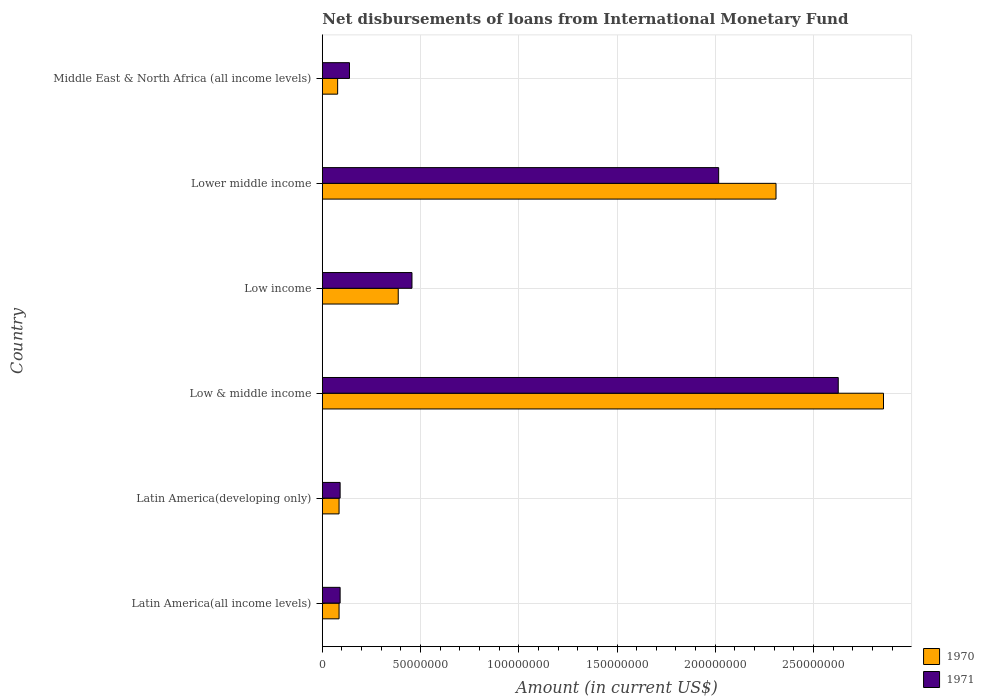What is the amount of loans disbursed in 1971 in Latin America(all income levels)?
Offer a very short reply. 9.06e+06. Across all countries, what is the maximum amount of loans disbursed in 1970?
Provide a succinct answer. 2.86e+08. Across all countries, what is the minimum amount of loans disbursed in 1971?
Keep it short and to the point. 9.06e+06. In which country was the amount of loans disbursed in 1970 minimum?
Your answer should be compact. Middle East & North Africa (all income levels). What is the total amount of loans disbursed in 1971 in the graph?
Your answer should be compact. 5.42e+08. What is the difference between the amount of loans disbursed in 1970 in Latin America(developing only) and that in Low & middle income?
Your answer should be very brief. -2.77e+08. What is the difference between the amount of loans disbursed in 1970 in Low income and the amount of loans disbursed in 1971 in Latin America(all income levels)?
Offer a very short reply. 2.96e+07. What is the average amount of loans disbursed in 1970 per country?
Provide a succinct answer. 9.67e+07. What is the difference between the amount of loans disbursed in 1971 and amount of loans disbursed in 1970 in Middle East & North Africa (all income levels)?
Offer a very short reply. 6.03e+06. In how many countries, is the amount of loans disbursed in 1971 greater than 280000000 US$?
Provide a short and direct response. 0. What is the ratio of the amount of loans disbursed in 1971 in Lower middle income to that in Middle East & North Africa (all income levels)?
Your response must be concise. 14.6. What is the difference between the highest and the second highest amount of loans disbursed in 1971?
Offer a very short reply. 6.09e+07. What is the difference between the highest and the lowest amount of loans disbursed in 1971?
Make the answer very short. 2.54e+08. In how many countries, is the amount of loans disbursed in 1971 greater than the average amount of loans disbursed in 1971 taken over all countries?
Offer a very short reply. 2. What does the 1st bar from the bottom in Middle East & North Africa (all income levels) represents?
Offer a terse response. 1970. What is the difference between two consecutive major ticks on the X-axis?
Offer a very short reply. 5.00e+07. Are the values on the major ticks of X-axis written in scientific E-notation?
Your response must be concise. No. Does the graph contain any zero values?
Give a very brief answer. No. How are the legend labels stacked?
Give a very brief answer. Vertical. What is the title of the graph?
Ensure brevity in your answer.  Net disbursements of loans from International Monetary Fund. What is the label or title of the Y-axis?
Your response must be concise. Country. What is the Amount (in current US$) of 1970 in Latin America(all income levels)?
Ensure brevity in your answer.  8.52e+06. What is the Amount (in current US$) in 1971 in Latin America(all income levels)?
Your response must be concise. 9.06e+06. What is the Amount (in current US$) in 1970 in Latin America(developing only)?
Keep it short and to the point. 8.52e+06. What is the Amount (in current US$) in 1971 in Latin America(developing only)?
Provide a short and direct response. 9.06e+06. What is the Amount (in current US$) of 1970 in Low & middle income?
Your answer should be very brief. 2.86e+08. What is the Amount (in current US$) of 1971 in Low & middle income?
Your answer should be very brief. 2.63e+08. What is the Amount (in current US$) in 1970 in Low income?
Ensure brevity in your answer.  3.86e+07. What is the Amount (in current US$) in 1971 in Low income?
Keep it short and to the point. 4.56e+07. What is the Amount (in current US$) of 1970 in Lower middle income?
Your answer should be very brief. 2.31e+08. What is the Amount (in current US$) in 1971 in Lower middle income?
Give a very brief answer. 2.02e+08. What is the Amount (in current US$) of 1970 in Middle East & North Africa (all income levels)?
Ensure brevity in your answer.  7.79e+06. What is the Amount (in current US$) of 1971 in Middle East & North Africa (all income levels)?
Give a very brief answer. 1.38e+07. Across all countries, what is the maximum Amount (in current US$) in 1970?
Keep it short and to the point. 2.86e+08. Across all countries, what is the maximum Amount (in current US$) of 1971?
Ensure brevity in your answer.  2.63e+08. Across all countries, what is the minimum Amount (in current US$) in 1970?
Provide a succinct answer. 7.79e+06. Across all countries, what is the minimum Amount (in current US$) in 1971?
Provide a succinct answer. 9.06e+06. What is the total Amount (in current US$) in 1970 in the graph?
Keep it short and to the point. 5.80e+08. What is the total Amount (in current US$) in 1971 in the graph?
Make the answer very short. 5.42e+08. What is the difference between the Amount (in current US$) of 1970 in Latin America(all income levels) and that in Low & middle income?
Your response must be concise. -2.77e+08. What is the difference between the Amount (in current US$) of 1971 in Latin America(all income levels) and that in Low & middle income?
Keep it short and to the point. -2.54e+08. What is the difference between the Amount (in current US$) in 1970 in Latin America(all income levels) and that in Low income?
Make the answer very short. -3.01e+07. What is the difference between the Amount (in current US$) in 1971 in Latin America(all income levels) and that in Low income?
Your answer should be very brief. -3.66e+07. What is the difference between the Amount (in current US$) in 1970 in Latin America(all income levels) and that in Lower middle income?
Provide a succinct answer. -2.22e+08. What is the difference between the Amount (in current US$) in 1971 in Latin America(all income levels) and that in Lower middle income?
Your answer should be very brief. -1.93e+08. What is the difference between the Amount (in current US$) in 1970 in Latin America(all income levels) and that in Middle East & North Africa (all income levels)?
Your answer should be very brief. 7.24e+05. What is the difference between the Amount (in current US$) in 1971 in Latin America(all income levels) and that in Middle East & North Africa (all income levels)?
Offer a terse response. -4.76e+06. What is the difference between the Amount (in current US$) of 1970 in Latin America(developing only) and that in Low & middle income?
Provide a short and direct response. -2.77e+08. What is the difference between the Amount (in current US$) in 1971 in Latin America(developing only) and that in Low & middle income?
Offer a terse response. -2.54e+08. What is the difference between the Amount (in current US$) in 1970 in Latin America(developing only) and that in Low income?
Ensure brevity in your answer.  -3.01e+07. What is the difference between the Amount (in current US$) in 1971 in Latin America(developing only) and that in Low income?
Ensure brevity in your answer.  -3.66e+07. What is the difference between the Amount (in current US$) of 1970 in Latin America(developing only) and that in Lower middle income?
Your answer should be very brief. -2.22e+08. What is the difference between the Amount (in current US$) in 1971 in Latin America(developing only) and that in Lower middle income?
Your answer should be very brief. -1.93e+08. What is the difference between the Amount (in current US$) in 1970 in Latin America(developing only) and that in Middle East & North Africa (all income levels)?
Your response must be concise. 7.24e+05. What is the difference between the Amount (in current US$) of 1971 in Latin America(developing only) and that in Middle East & North Africa (all income levels)?
Offer a terse response. -4.76e+06. What is the difference between the Amount (in current US$) in 1970 in Low & middle income and that in Low income?
Your response must be concise. 2.47e+08. What is the difference between the Amount (in current US$) of 1971 in Low & middle income and that in Low income?
Your answer should be very brief. 2.17e+08. What is the difference between the Amount (in current US$) in 1970 in Low & middle income and that in Lower middle income?
Your answer should be very brief. 5.47e+07. What is the difference between the Amount (in current US$) in 1971 in Low & middle income and that in Lower middle income?
Give a very brief answer. 6.09e+07. What is the difference between the Amount (in current US$) in 1970 in Low & middle income and that in Middle East & North Africa (all income levels)?
Your response must be concise. 2.78e+08. What is the difference between the Amount (in current US$) of 1971 in Low & middle income and that in Middle East & North Africa (all income levels)?
Offer a terse response. 2.49e+08. What is the difference between the Amount (in current US$) in 1970 in Low income and that in Lower middle income?
Your answer should be very brief. -1.92e+08. What is the difference between the Amount (in current US$) of 1971 in Low income and that in Lower middle income?
Make the answer very short. -1.56e+08. What is the difference between the Amount (in current US$) of 1970 in Low income and that in Middle East & North Africa (all income levels)?
Ensure brevity in your answer.  3.08e+07. What is the difference between the Amount (in current US$) of 1971 in Low income and that in Middle East & North Africa (all income levels)?
Your answer should be very brief. 3.18e+07. What is the difference between the Amount (in current US$) in 1970 in Lower middle income and that in Middle East & North Africa (all income levels)?
Ensure brevity in your answer.  2.23e+08. What is the difference between the Amount (in current US$) of 1971 in Lower middle income and that in Middle East & North Africa (all income levels)?
Keep it short and to the point. 1.88e+08. What is the difference between the Amount (in current US$) in 1970 in Latin America(all income levels) and the Amount (in current US$) in 1971 in Latin America(developing only)?
Ensure brevity in your answer.  -5.44e+05. What is the difference between the Amount (in current US$) in 1970 in Latin America(all income levels) and the Amount (in current US$) in 1971 in Low & middle income?
Make the answer very short. -2.54e+08. What is the difference between the Amount (in current US$) of 1970 in Latin America(all income levels) and the Amount (in current US$) of 1971 in Low income?
Make the answer very short. -3.71e+07. What is the difference between the Amount (in current US$) in 1970 in Latin America(all income levels) and the Amount (in current US$) in 1971 in Lower middle income?
Your answer should be very brief. -1.93e+08. What is the difference between the Amount (in current US$) of 1970 in Latin America(all income levels) and the Amount (in current US$) of 1971 in Middle East & North Africa (all income levels)?
Give a very brief answer. -5.30e+06. What is the difference between the Amount (in current US$) in 1970 in Latin America(developing only) and the Amount (in current US$) in 1971 in Low & middle income?
Your answer should be very brief. -2.54e+08. What is the difference between the Amount (in current US$) of 1970 in Latin America(developing only) and the Amount (in current US$) of 1971 in Low income?
Make the answer very short. -3.71e+07. What is the difference between the Amount (in current US$) in 1970 in Latin America(developing only) and the Amount (in current US$) in 1971 in Lower middle income?
Make the answer very short. -1.93e+08. What is the difference between the Amount (in current US$) of 1970 in Latin America(developing only) and the Amount (in current US$) of 1971 in Middle East & North Africa (all income levels)?
Provide a succinct answer. -5.30e+06. What is the difference between the Amount (in current US$) of 1970 in Low & middle income and the Amount (in current US$) of 1971 in Low income?
Offer a terse response. 2.40e+08. What is the difference between the Amount (in current US$) in 1970 in Low & middle income and the Amount (in current US$) in 1971 in Lower middle income?
Your response must be concise. 8.39e+07. What is the difference between the Amount (in current US$) in 1970 in Low & middle income and the Amount (in current US$) in 1971 in Middle East & North Africa (all income levels)?
Offer a very short reply. 2.72e+08. What is the difference between the Amount (in current US$) in 1970 in Low income and the Amount (in current US$) in 1971 in Lower middle income?
Provide a short and direct response. -1.63e+08. What is the difference between the Amount (in current US$) of 1970 in Low income and the Amount (in current US$) of 1971 in Middle East & North Africa (all income levels)?
Provide a short and direct response. 2.48e+07. What is the difference between the Amount (in current US$) of 1970 in Lower middle income and the Amount (in current US$) of 1971 in Middle East & North Africa (all income levels)?
Provide a short and direct response. 2.17e+08. What is the average Amount (in current US$) of 1970 per country?
Provide a succinct answer. 9.67e+07. What is the average Amount (in current US$) in 1971 per country?
Keep it short and to the point. 9.03e+07. What is the difference between the Amount (in current US$) in 1970 and Amount (in current US$) in 1971 in Latin America(all income levels)?
Your answer should be very brief. -5.44e+05. What is the difference between the Amount (in current US$) in 1970 and Amount (in current US$) in 1971 in Latin America(developing only)?
Your response must be concise. -5.44e+05. What is the difference between the Amount (in current US$) in 1970 and Amount (in current US$) in 1971 in Low & middle income?
Keep it short and to the point. 2.30e+07. What is the difference between the Amount (in current US$) of 1970 and Amount (in current US$) of 1971 in Low income?
Give a very brief answer. -6.99e+06. What is the difference between the Amount (in current US$) of 1970 and Amount (in current US$) of 1971 in Lower middle income?
Ensure brevity in your answer.  2.92e+07. What is the difference between the Amount (in current US$) in 1970 and Amount (in current US$) in 1971 in Middle East & North Africa (all income levels)?
Provide a succinct answer. -6.03e+06. What is the ratio of the Amount (in current US$) of 1970 in Latin America(all income levels) to that in Latin America(developing only)?
Offer a terse response. 1. What is the ratio of the Amount (in current US$) of 1970 in Latin America(all income levels) to that in Low & middle income?
Offer a terse response. 0.03. What is the ratio of the Amount (in current US$) in 1971 in Latin America(all income levels) to that in Low & middle income?
Make the answer very short. 0.03. What is the ratio of the Amount (in current US$) in 1970 in Latin America(all income levels) to that in Low income?
Your answer should be compact. 0.22. What is the ratio of the Amount (in current US$) in 1971 in Latin America(all income levels) to that in Low income?
Provide a short and direct response. 0.2. What is the ratio of the Amount (in current US$) in 1970 in Latin America(all income levels) to that in Lower middle income?
Your answer should be very brief. 0.04. What is the ratio of the Amount (in current US$) in 1971 in Latin America(all income levels) to that in Lower middle income?
Offer a very short reply. 0.04. What is the ratio of the Amount (in current US$) in 1970 in Latin America(all income levels) to that in Middle East & North Africa (all income levels)?
Your answer should be compact. 1.09. What is the ratio of the Amount (in current US$) of 1971 in Latin America(all income levels) to that in Middle East & North Africa (all income levels)?
Ensure brevity in your answer.  0.66. What is the ratio of the Amount (in current US$) of 1970 in Latin America(developing only) to that in Low & middle income?
Provide a succinct answer. 0.03. What is the ratio of the Amount (in current US$) in 1971 in Latin America(developing only) to that in Low & middle income?
Provide a short and direct response. 0.03. What is the ratio of the Amount (in current US$) in 1970 in Latin America(developing only) to that in Low income?
Your answer should be very brief. 0.22. What is the ratio of the Amount (in current US$) of 1971 in Latin America(developing only) to that in Low income?
Offer a very short reply. 0.2. What is the ratio of the Amount (in current US$) in 1970 in Latin America(developing only) to that in Lower middle income?
Your answer should be very brief. 0.04. What is the ratio of the Amount (in current US$) of 1971 in Latin America(developing only) to that in Lower middle income?
Make the answer very short. 0.04. What is the ratio of the Amount (in current US$) of 1970 in Latin America(developing only) to that in Middle East & North Africa (all income levels)?
Offer a terse response. 1.09. What is the ratio of the Amount (in current US$) in 1971 in Latin America(developing only) to that in Middle East & North Africa (all income levels)?
Keep it short and to the point. 0.66. What is the ratio of the Amount (in current US$) in 1970 in Low & middle income to that in Low income?
Provide a short and direct response. 7.39. What is the ratio of the Amount (in current US$) in 1971 in Low & middle income to that in Low income?
Your response must be concise. 5.76. What is the ratio of the Amount (in current US$) in 1970 in Low & middle income to that in Lower middle income?
Ensure brevity in your answer.  1.24. What is the ratio of the Amount (in current US$) in 1971 in Low & middle income to that in Lower middle income?
Provide a succinct answer. 1.3. What is the ratio of the Amount (in current US$) of 1970 in Low & middle income to that in Middle East & North Africa (all income levels)?
Ensure brevity in your answer.  36.65. What is the ratio of the Amount (in current US$) in 1971 in Low & middle income to that in Middle East & North Africa (all income levels)?
Provide a succinct answer. 19. What is the ratio of the Amount (in current US$) of 1970 in Low income to that in Lower middle income?
Offer a terse response. 0.17. What is the ratio of the Amount (in current US$) in 1971 in Low income to that in Lower middle income?
Your answer should be compact. 0.23. What is the ratio of the Amount (in current US$) of 1970 in Low income to that in Middle East & North Africa (all income levels)?
Your answer should be very brief. 4.96. What is the ratio of the Amount (in current US$) of 1971 in Low income to that in Middle East & North Africa (all income levels)?
Keep it short and to the point. 3.3. What is the ratio of the Amount (in current US$) in 1970 in Lower middle income to that in Middle East & North Africa (all income levels)?
Your answer should be compact. 29.63. What is the ratio of the Amount (in current US$) in 1971 in Lower middle income to that in Middle East & North Africa (all income levels)?
Offer a terse response. 14.6. What is the difference between the highest and the second highest Amount (in current US$) in 1970?
Give a very brief answer. 5.47e+07. What is the difference between the highest and the second highest Amount (in current US$) in 1971?
Offer a very short reply. 6.09e+07. What is the difference between the highest and the lowest Amount (in current US$) in 1970?
Keep it short and to the point. 2.78e+08. What is the difference between the highest and the lowest Amount (in current US$) in 1971?
Ensure brevity in your answer.  2.54e+08. 